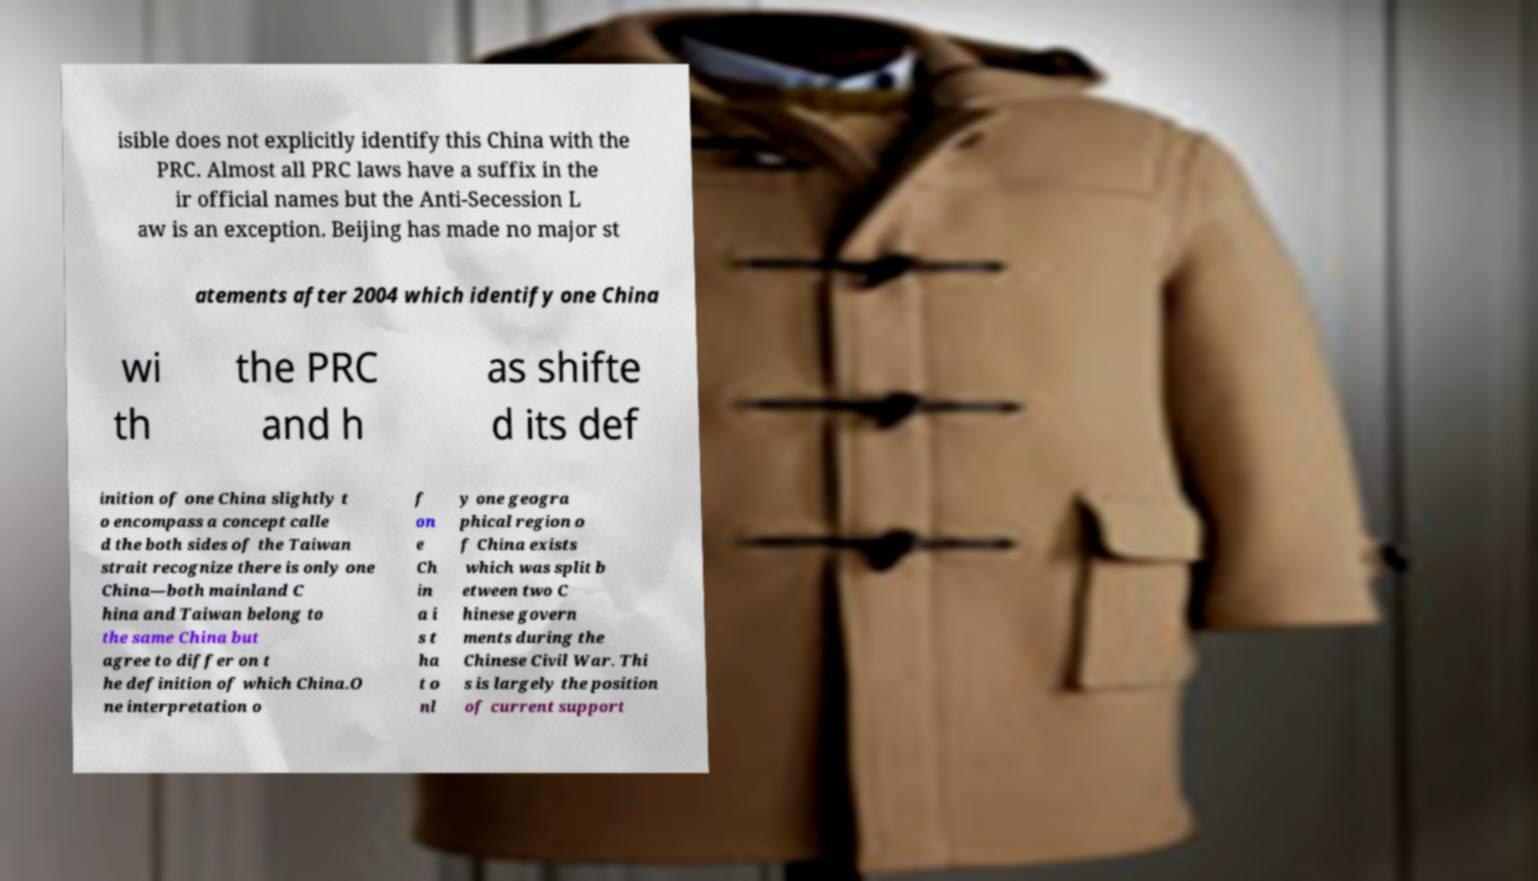Please read and relay the text visible in this image. What does it say? isible does not explicitly identify this China with the PRC. Almost all PRC laws have a suffix in the ir official names but the Anti-Secession L aw is an exception. Beijing has made no major st atements after 2004 which identify one China wi th the PRC and h as shifte d its def inition of one China slightly t o encompass a concept calle d the both sides of the Taiwan strait recognize there is only one China—both mainland C hina and Taiwan belong to the same China but agree to differ on t he definition of which China.O ne interpretation o f on e Ch in a i s t ha t o nl y one geogra phical region o f China exists which was split b etween two C hinese govern ments during the Chinese Civil War. Thi s is largely the position of current support 